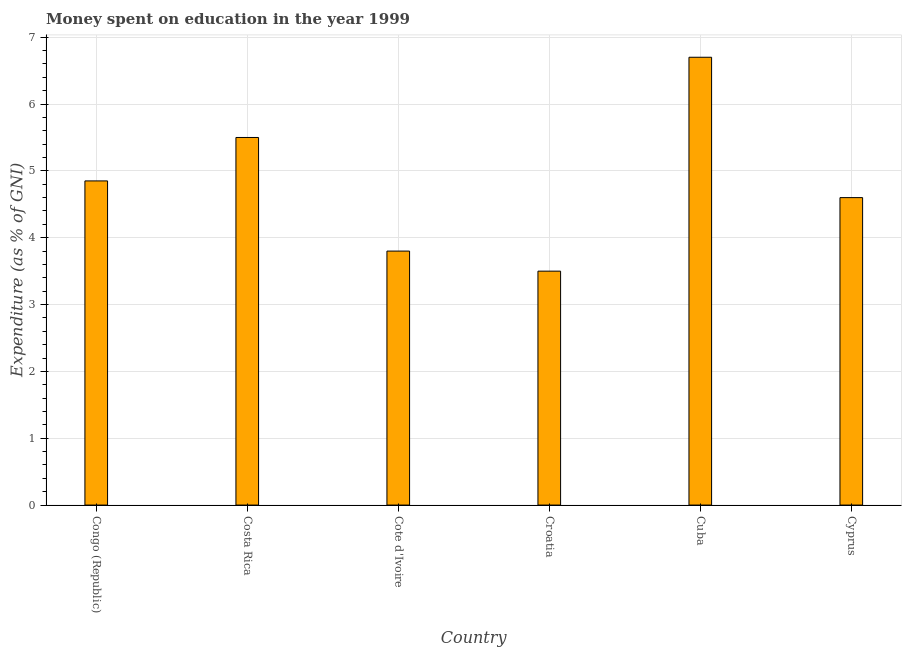What is the title of the graph?
Your response must be concise. Money spent on education in the year 1999. What is the label or title of the X-axis?
Make the answer very short. Country. What is the label or title of the Y-axis?
Your answer should be compact. Expenditure (as % of GNI). Across all countries, what is the maximum expenditure on education?
Provide a succinct answer. 6.7. Across all countries, what is the minimum expenditure on education?
Keep it short and to the point. 3.5. In which country was the expenditure on education maximum?
Offer a terse response. Cuba. In which country was the expenditure on education minimum?
Provide a succinct answer. Croatia. What is the sum of the expenditure on education?
Give a very brief answer. 28.95. What is the difference between the expenditure on education in Congo (Republic) and Costa Rica?
Make the answer very short. -0.65. What is the average expenditure on education per country?
Your response must be concise. 4.83. What is the median expenditure on education?
Provide a short and direct response. 4.72. In how many countries, is the expenditure on education greater than 6.6 %?
Provide a succinct answer. 1. What is the ratio of the expenditure on education in Costa Rica to that in Croatia?
Make the answer very short. 1.57. In how many countries, is the expenditure on education greater than the average expenditure on education taken over all countries?
Ensure brevity in your answer.  3. How many bars are there?
Provide a short and direct response. 6. What is the Expenditure (as % of GNI) of Congo (Republic)?
Your answer should be compact. 4.85. What is the Expenditure (as % of GNI) in Costa Rica?
Your answer should be compact. 5.5. What is the Expenditure (as % of GNI) in Cote d'Ivoire?
Provide a succinct answer. 3.8. What is the Expenditure (as % of GNI) of Cuba?
Make the answer very short. 6.7. What is the Expenditure (as % of GNI) of Cyprus?
Your answer should be very brief. 4.6. What is the difference between the Expenditure (as % of GNI) in Congo (Republic) and Costa Rica?
Provide a succinct answer. -0.65. What is the difference between the Expenditure (as % of GNI) in Congo (Republic) and Cote d'Ivoire?
Your answer should be very brief. 1.05. What is the difference between the Expenditure (as % of GNI) in Congo (Republic) and Croatia?
Offer a very short reply. 1.35. What is the difference between the Expenditure (as % of GNI) in Congo (Republic) and Cuba?
Make the answer very short. -1.85. What is the difference between the Expenditure (as % of GNI) in Congo (Republic) and Cyprus?
Offer a very short reply. 0.25. What is the difference between the Expenditure (as % of GNI) in Costa Rica and Croatia?
Your answer should be compact. 2. What is the difference between the Expenditure (as % of GNI) in Cote d'Ivoire and Croatia?
Provide a succinct answer. 0.3. What is the difference between the Expenditure (as % of GNI) in Cote d'Ivoire and Cuba?
Make the answer very short. -2.9. What is the difference between the Expenditure (as % of GNI) in Croatia and Cuba?
Your answer should be very brief. -3.2. What is the difference between the Expenditure (as % of GNI) in Cuba and Cyprus?
Your response must be concise. 2.1. What is the ratio of the Expenditure (as % of GNI) in Congo (Republic) to that in Costa Rica?
Your answer should be compact. 0.88. What is the ratio of the Expenditure (as % of GNI) in Congo (Republic) to that in Cote d'Ivoire?
Ensure brevity in your answer.  1.28. What is the ratio of the Expenditure (as % of GNI) in Congo (Republic) to that in Croatia?
Your answer should be very brief. 1.39. What is the ratio of the Expenditure (as % of GNI) in Congo (Republic) to that in Cuba?
Offer a very short reply. 0.72. What is the ratio of the Expenditure (as % of GNI) in Congo (Republic) to that in Cyprus?
Ensure brevity in your answer.  1.05. What is the ratio of the Expenditure (as % of GNI) in Costa Rica to that in Cote d'Ivoire?
Give a very brief answer. 1.45. What is the ratio of the Expenditure (as % of GNI) in Costa Rica to that in Croatia?
Your response must be concise. 1.57. What is the ratio of the Expenditure (as % of GNI) in Costa Rica to that in Cuba?
Offer a very short reply. 0.82. What is the ratio of the Expenditure (as % of GNI) in Costa Rica to that in Cyprus?
Keep it short and to the point. 1.2. What is the ratio of the Expenditure (as % of GNI) in Cote d'Ivoire to that in Croatia?
Offer a terse response. 1.09. What is the ratio of the Expenditure (as % of GNI) in Cote d'Ivoire to that in Cuba?
Your answer should be very brief. 0.57. What is the ratio of the Expenditure (as % of GNI) in Cote d'Ivoire to that in Cyprus?
Your answer should be very brief. 0.83. What is the ratio of the Expenditure (as % of GNI) in Croatia to that in Cuba?
Make the answer very short. 0.52. What is the ratio of the Expenditure (as % of GNI) in Croatia to that in Cyprus?
Make the answer very short. 0.76. What is the ratio of the Expenditure (as % of GNI) in Cuba to that in Cyprus?
Provide a succinct answer. 1.46. 